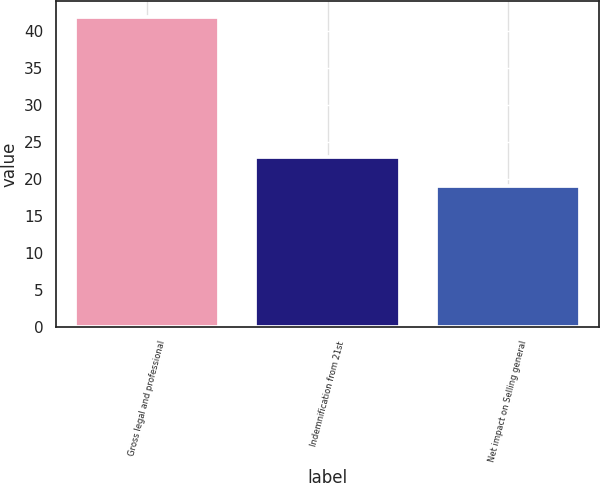<chart> <loc_0><loc_0><loc_500><loc_500><bar_chart><fcel>Gross legal and professional<fcel>Indemnification from 21st<fcel>Net impact on Selling general<nl><fcel>42<fcel>23<fcel>19<nl></chart> 